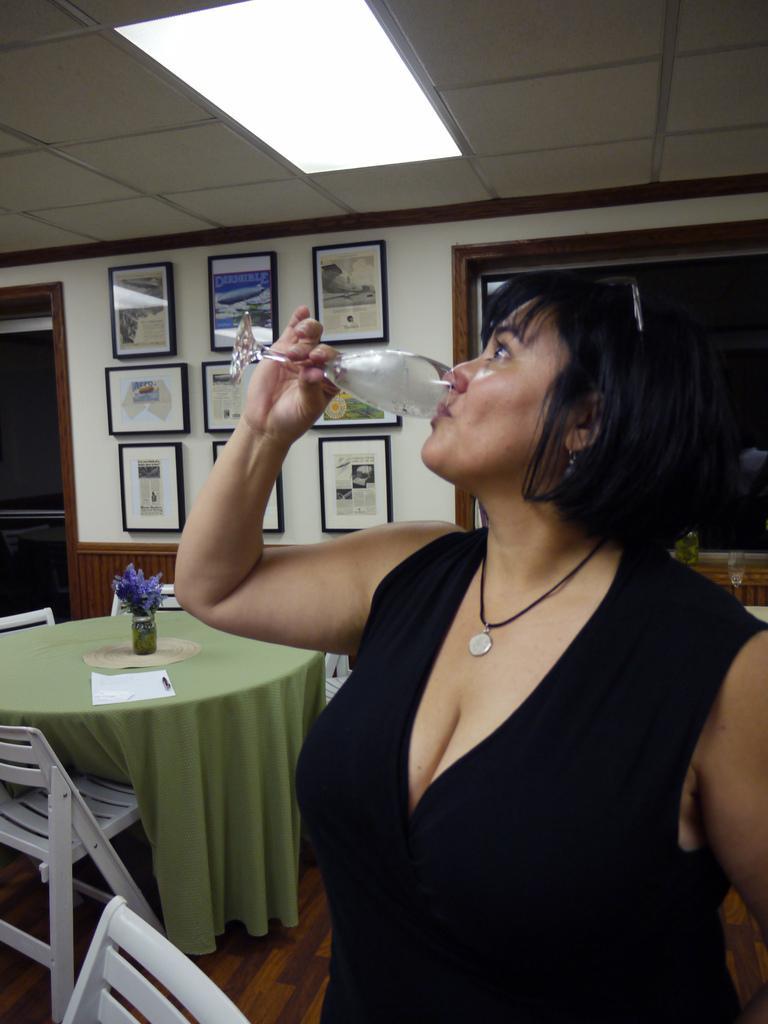Please provide a concise description of this image. In this image there is a lady holding a glass and drinking some drink, there are frames attached to the wall, there are chairs, a flower vase on the table, windows and ceiling. 